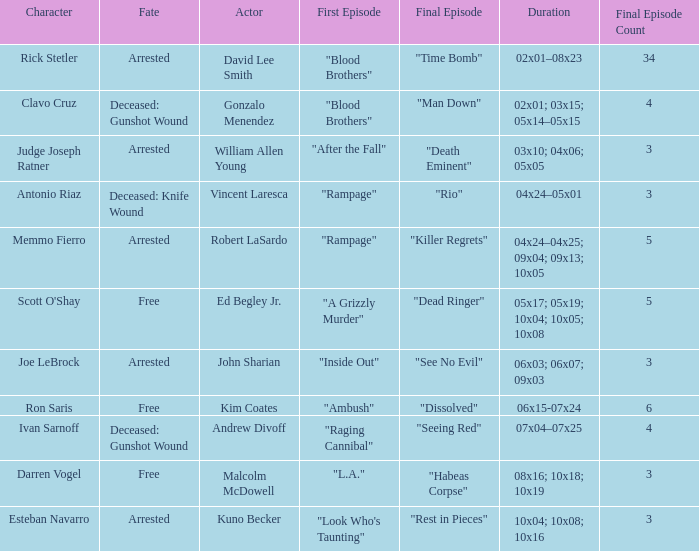In which actor's role can we find judge joseph ratner's character? William Allen Young. 